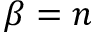Convert formula to latex. <formula><loc_0><loc_0><loc_500><loc_500>\beta = n</formula> 